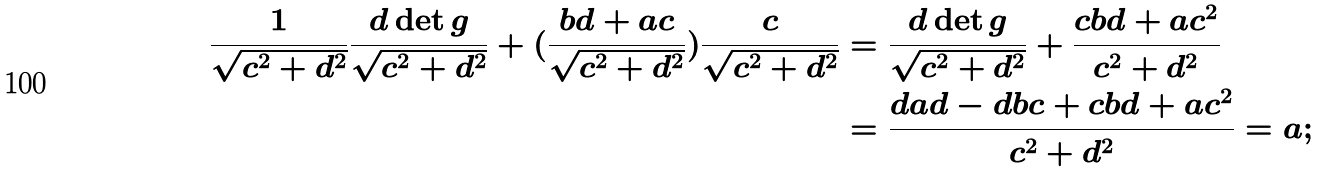Convert formula to latex. <formula><loc_0><loc_0><loc_500><loc_500>\frac { 1 } { \sqrt { c ^ { 2 } + d ^ { 2 } } } \frac { d \det g } { \sqrt { c ^ { 2 } + d ^ { 2 } } } + ( \frac { b d + a c } { \sqrt { c ^ { 2 } + d ^ { 2 } } } ) \frac { c } { \sqrt { c ^ { 2 } + d ^ { 2 } } } & = \frac { d \det g } { \sqrt { c ^ { 2 } + d ^ { 2 } } } + \frac { c b d + a c ^ { 2 } } { c ^ { 2 } + d ^ { 2 } } \\ & = \frac { d a d - d b c + c b d + a c ^ { 2 } } { c ^ { 2 } + d ^ { 2 } } = a ;</formula> 